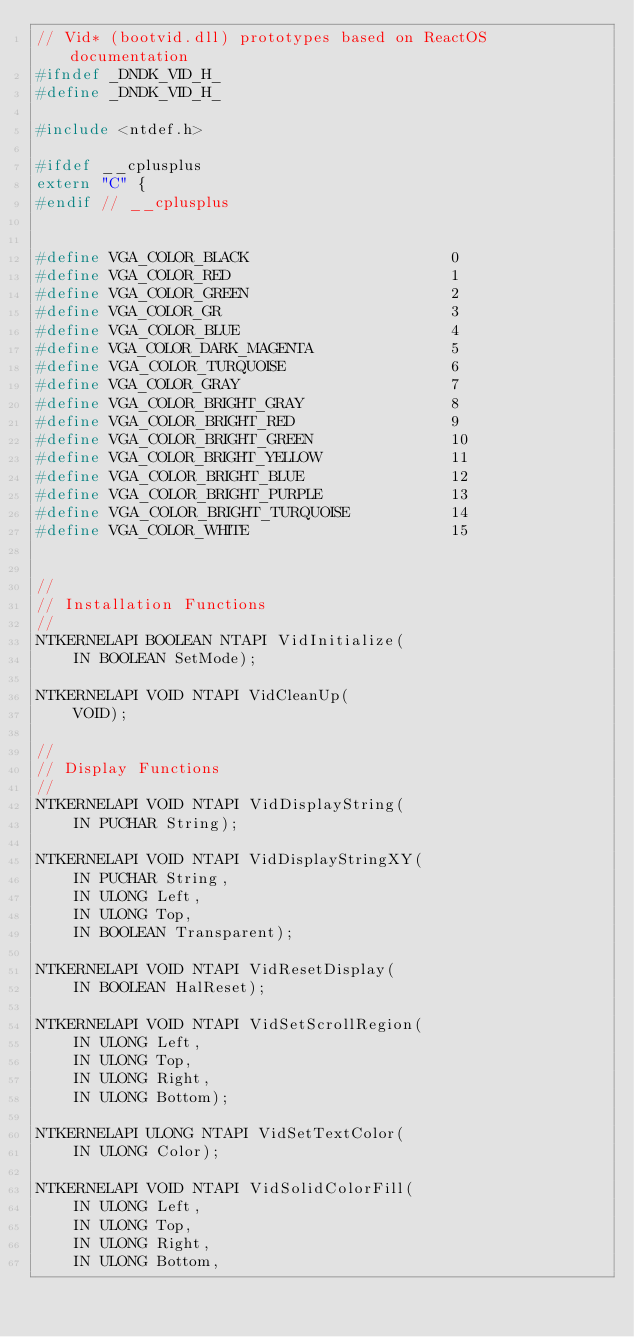Convert code to text. <code><loc_0><loc_0><loc_500><loc_500><_C_>// Vid* (bootvid.dll) prototypes based on ReactOS documentation
#ifndef _DNDK_VID_H_
#define _DNDK_VID_H_

#include <ntdef.h>

#ifdef __cplusplus
extern "C" {
#endif // __cplusplus


#define VGA_COLOR_BLACK                      0
#define VGA_COLOR_RED                        1
#define VGA_COLOR_GREEN                      2
#define VGA_COLOR_GR                         3
#define VGA_COLOR_BLUE                       4
#define VGA_COLOR_DARK_MAGENTA               5
#define VGA_COLOR_TURQUOISE                  6
#define VGA_COLOR_GRAY                       7
#define VGA_COLOR_BRIGHT_GRAY                8
#define VGA_COLOR_BRIGHT_RED                 9
#define VGA_COLOR_BRIGHT_GREEN               10
#define VGA_COLOR_BRIGHT_YELLOW              11
#define VGA_COLOR_BRIGHT_BLUE                12
#define VGA_COLOR_BRIGHT_PURPLE              13
#define VGA_COLOR_BRIGHT_TURQUOISE           14
#define VGA_COLOR_WHITE                      15


//
// Installation Functions
//
NTKERNELAPI BOOLEAN NTAPI VidInitialize(
    IN BOOLEAN SetMode);

NTKERNELAPI VOID NTAPI VidCleanUp(
    VOID);

//
// Display Functions
//
NTKERNELAPI VOID NTAPI VidDisplayString(
    IN PUCHAR String);

NTKERNELAPI VOID NTAPI VidDisplayStringXY(
    IN PUCHAR String,
    IN ULONG Left,
    IN ULONG Top,
    IN BOOLEAN Transparent);

NTKERNELAPI VOID NTAPI VidResetDisplay(
    IN BOOLEAN HalReset);

NTKERNELAPI VOID NTAPI VidSetScrollRegion(
    IN ULONG Left,
    IN ULONG Top,
    IN ULONG Right,
    IN ULONG Bottom);

NTKERNELAPI ULONG NTAPI VidSetTextColor(
    IN ULONG Color);

NTKERNELAPI VOID NTAPI VidSolidColorFill(
    IN ULONG Left,
    IN ULONG Top,
    IN ULONG Right,
    IN ULONG Bottom,</code> 